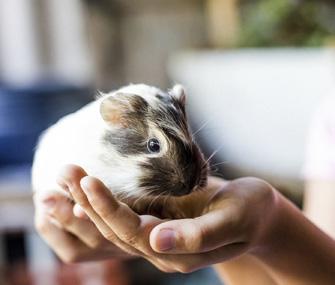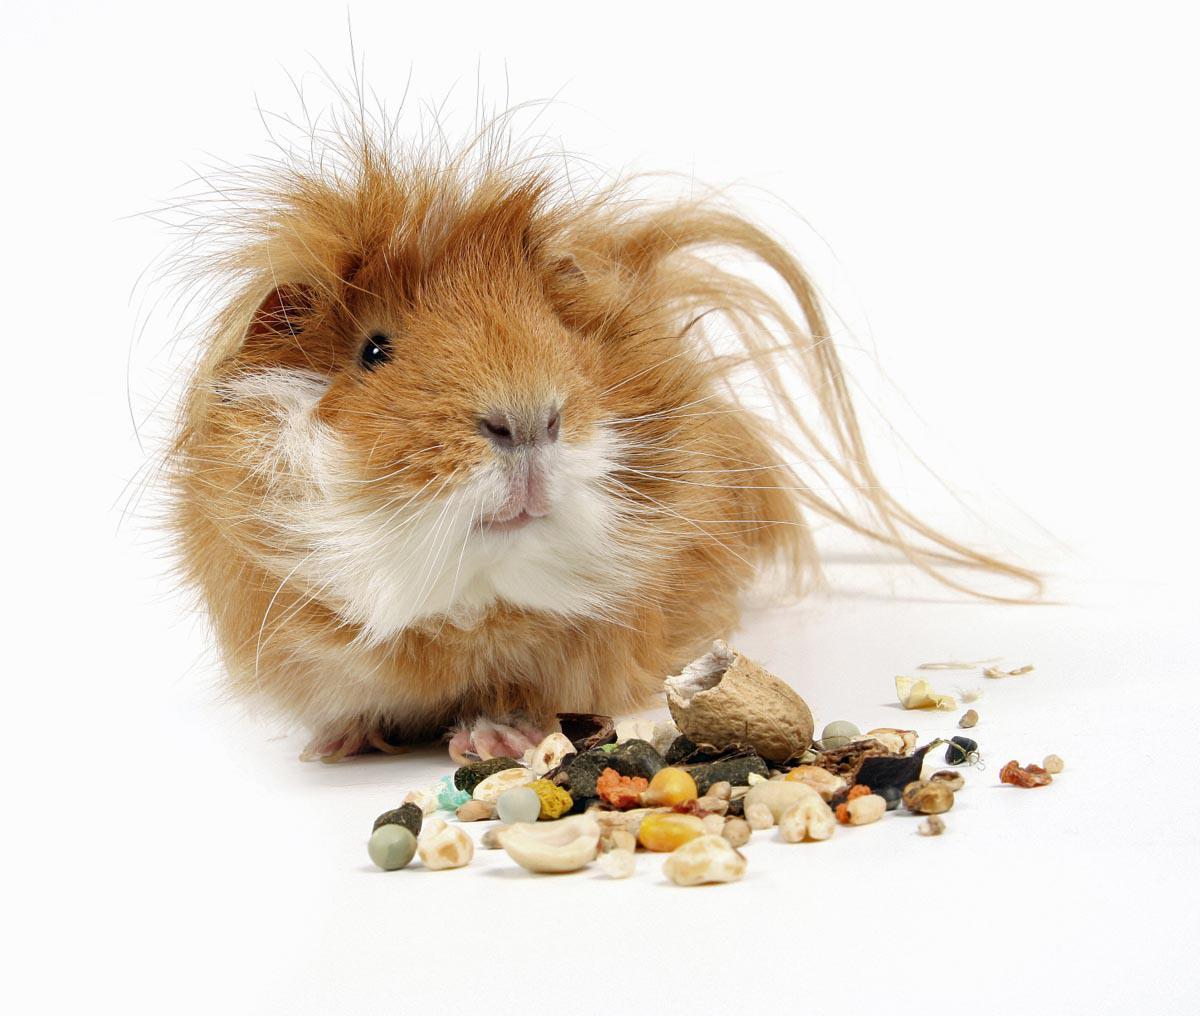The first image is the image on the left, the second image is the image on the right. Assess this claim about the two images: "A person is holding one of the animals.". Correct or not? Answer yes or no. Yes. 